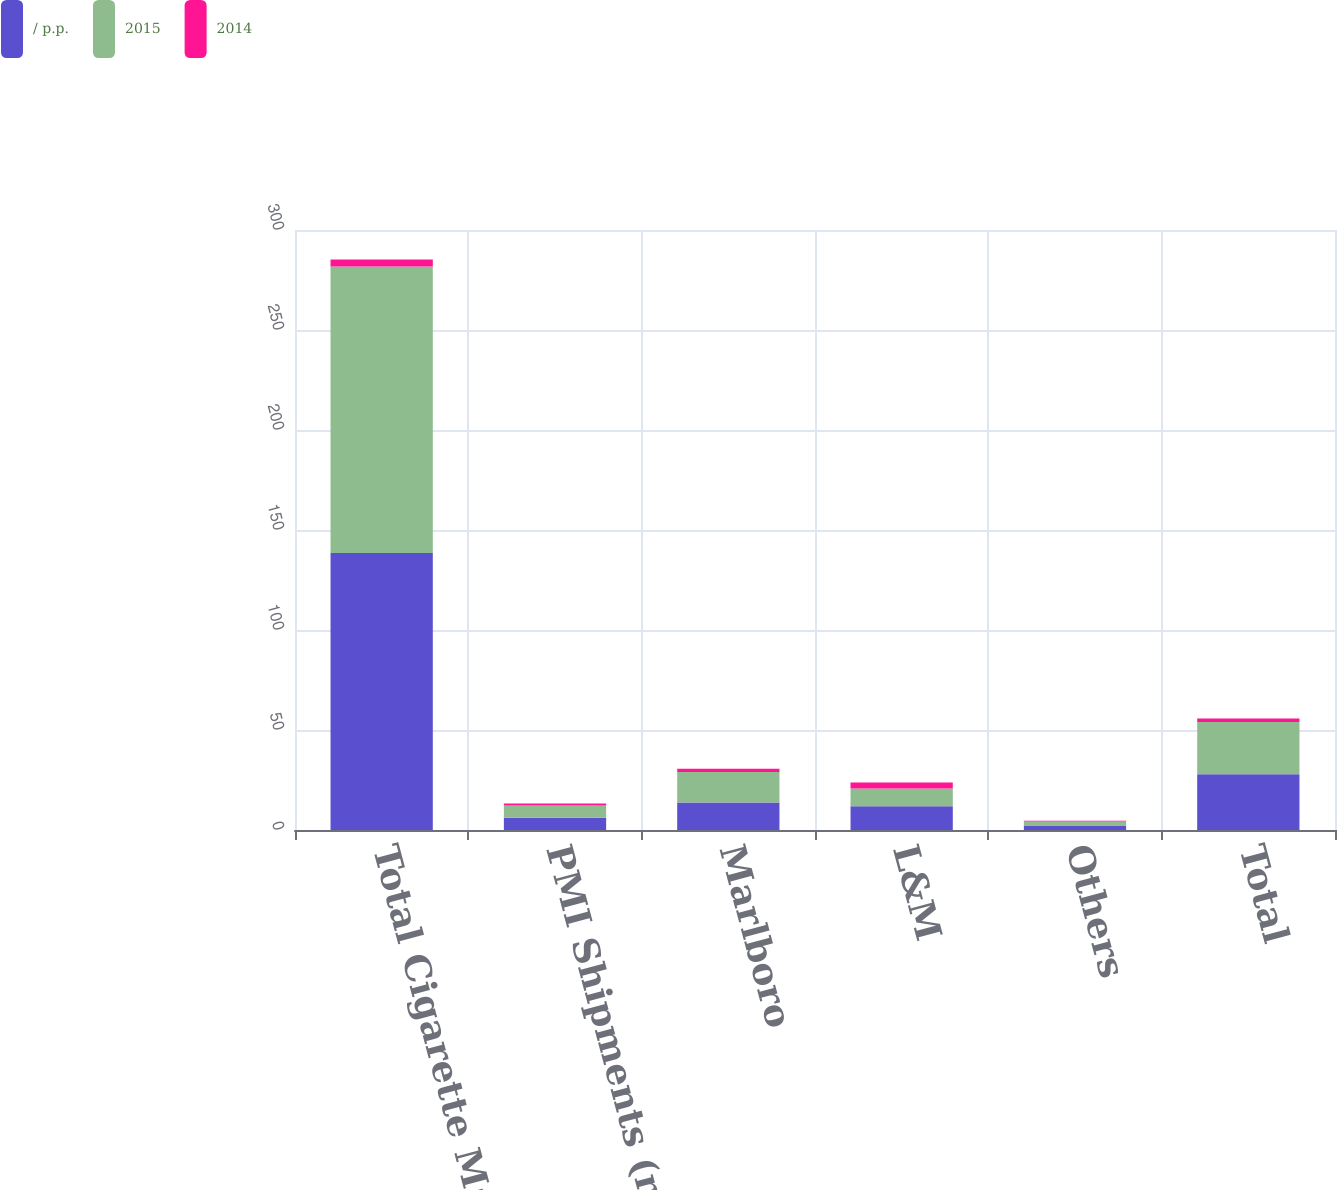<chart> <loc_0><loc_0><loc_500><loc_500><stacked_bar_chart><ecel><fcel>Total Cigarette Market<fcel>PMI Shipments (million units)<fcel>Marlboro<fcel>L&M<fcel>Others<fcel>Total<nl><fcel>/ p.p.<fcel>138.5<fcel>6.15<fcel>13.7<fcel>11.9<fcel>2.3<fcel>27.9<nl><fcel>2015<fcel>143.3<fcel>6.15<fcel>15.3<fcel>8.9<fcel>1.9<fcel>26.1<nl><fcel>2014<fcel>3.4<fcel>0.9<fcel>1.6<fcel>3<fcel>0.4<fcel>1.8<nl></chart> 